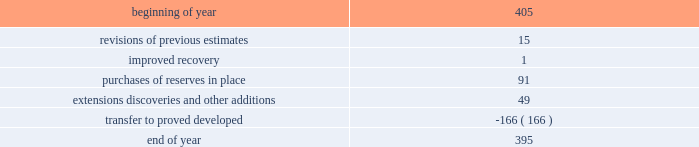For the estimates of our oil sands mining reserves has 33 years of experience in petroleum engineering and has conducted surface mineable oil sands evaluations since 1986 .
He is a member of spe , having served as regional director from 1998 through 2001 and is a registered practicing professional engineer in the province of alberta .
Audits of estimates third-party consultants are engaged to provide independent estimates for fields that comprise 80 percent of our total proved reserves over a rolling four-year period for the purpose of auditing the in-house reserve estimates .
We met this goal for the four-year period ended december 31 , 2011 .
We established a tolerance level of 10 percent such that initial estimates by the third-party consultants are accepted if they are within 10 percent of our internal estimates .
Should the third-party consultants 2019 initial analysis fail to reach our tolerance level , both our team and the consultants re-examine the information provided , request additional data and refine their analysis if appropriate .
This resolution process is continued until both estimates are within 10 percent .
This process did not result in significant changes to our reserve estimates in 2011 or 2009 .
There were no third-party audits performed in 2010 .
During 2011 , netherland , sewell & associates , inc .
( 201cnsai 201d ) prepared a certification of december 31 , 2010 reserves for the alba field in equatorial guinea .
The nsai summary report is filed as an exhibit to this annual report on form 10-k .
The senior members of the nsai team have over 50 years of industry experience between them , having worked for large , international oil and gas companies before joining nsai .
The team lead has a master of science in mechanical engineering and is a member of spe .
The senior technical advisor has a bachelor of science degree in geophysics and is a member of the society of exploration geophysicists , the american association of petroleum geologists and the european association of geoscientists and engineers .
Both are licensed in the state of texas .
Ryder scott company ( 201cryder scott 201d ) performed audits of several of our fields in 2011 and 2009 .
Their summary report on audits performed in 2011 is filed as an exhibit to this annual report on form 10-k .
The team lead for ryder scott has over 20 years of industry experience , having worked for a major international oil and gas company before joining ryder scott .
He has a bachelor of science degree in mechanical engineering , is a member of spe and is a registered professional engineer in the state of texas .
The corporate reserves group also performs separate , detailed technical reviews of reserve estimates for significant fields that were acquired recently or for properties with other indicators such as excessively short or long lives , performance above or below expectations or changes in economic or operating conditions .
Changes in proved undeveloped reserves as of december 31 , 2011 , 395 mmboe of proved undeveloped reserves were reported , a decrease of 10 mmboe from december 31 , 2010 .
The table shows changes in total proved undeveloped reserves for 2011: .
Significant additions to proved undeveloped reserves during 2011 include 91 mmboe due to acreage acquisition in the eagle ford shale , 26 mmboe related to anadarko woodford shale development , 10 mmboe for development drilling in the bakken shale play and 8 mmboe for additional drilling in norway .
Additionally , 139 mmboe were transferred from proved undeveloped to proved developed reserves due to startup of the jackpine upgrader expansion in canada .
Costs incurred in 2011 , 2010 and 2009 relating to the development of proved undeveloped reserves , were $ 1107 million , $ 1463 million and $ 792 million .
Projects can remain in proved undeveloped reserves for extended periods in certain situations such as behind-pipe zones where reserves will not be accessed until the primary producing zone depletes , large development projects which take more than five years to complete , and the timing of when additional gas compression is needed .
Of the 395 mmboe of proved undeveloped reserves at year end 2011 , 34 percent of the volume is associated with projects that have been included in proved reserves for more than five years .
The majority of this volume is related to a compression project in equatorial guinea that was sanctioned by our board of directors in 2004 and is expected to be completed by 2016 .
Performance of this field has exceeded expectations , and estimates of initial dry gas in place increased by roughly 10 percent between 2004 and 2010 .
Production is not expected to experience a natural decline from facility-limited plateau production until 2014 , or possibly 2015 .
The timing of the installation of compression is being driven by the reservoir performance. .
What were total costs incurred in 2011 , 2010 and 2009 relating to the development of proved undeveloped reserves , in millions? 
Computations: ((1107 + 1463) + 792)
Answer: 3362.0. 